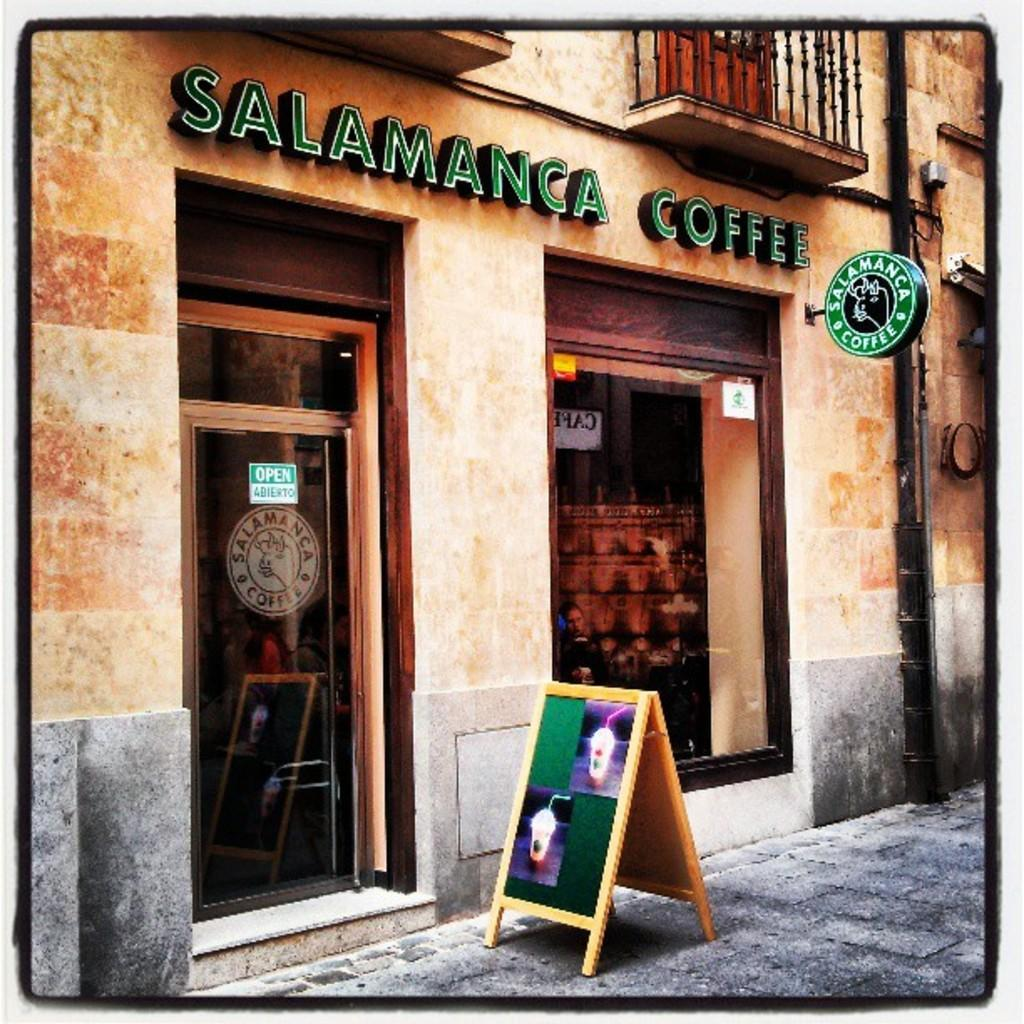<image>
Provide a brief description of the given image. A small coffee shop has a sign naming it Salamanca Coffee. 